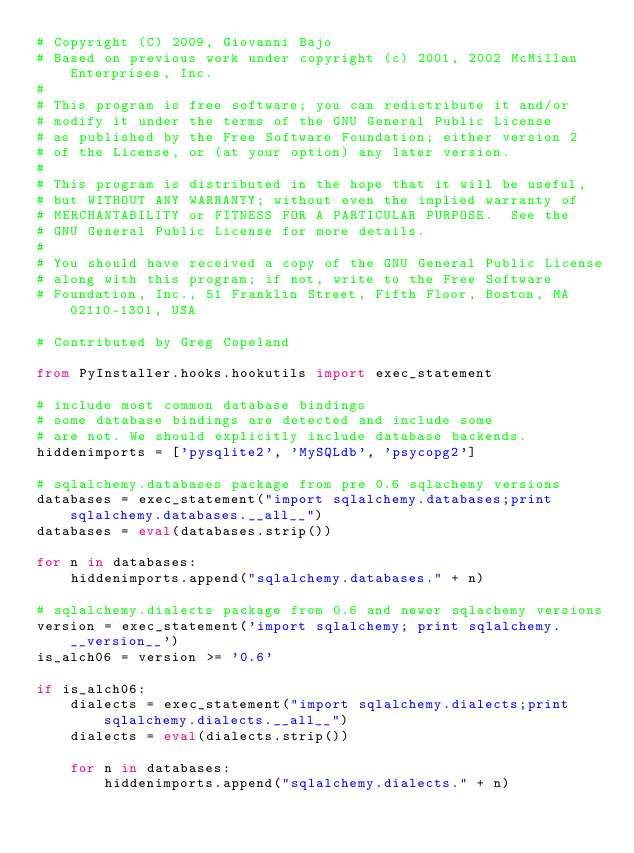Convert code to text. <code><loc_0><loc_0><loc_500><loc_500><_Python_># Copyright (C) 2009, Giovanni Bajo
# Based on previous work under copyright (c) 2001, 2002 McMillan Enterprises, Inc.
#
# This program is free software; you can redistribute it and/or
# modify it under the terms of the GNU General Public License
# as published by the Free Software Foundation; either version 2
# of the License, or (at your option) any later version.
#
# This program is distributed in the hope that it will be useful,
# but WITHOUT ANY WARRANTY; without even the implied warranty of
# MERCHANTABILITY or FITNESS FOR A PARTICULAR PURPOSE.  See the
# GNU General Public License for more details.
#
# You should have received a copy of the GNU General Public License
# along with this program; if not, write to the Free Software
# Foundation, Inc., 51 Franklin Street, Fifth Floor, Boston, MA  02110-1301, USA

# Contributed by Greg Copeland

from PyInstaller.hooks.hookutils import exec_statement

# include most common database bindings
# some database bindings are detected and include some
# are not. We should explicitly include database backends.
hiddenimports = ['pysqlite2', 'MySQLdb', 'psycopg2']

# sqlalchemy.databases package from pre 0.6 sqlachemy versions
databases = exec_statement("import sqlalchemy.databases;print sqlalchemy.databases.__all__")
databases = eval(databases.strip())

for n in databases:
    hiddenimports.append("sqlalchemy.databases." + n)

# sqlalchemy.dialects package from 0.6 and newer sqlachemy versions
version = exec_statement('import sqlalchemy; print sqlalchemy.__version__')
is_alch06 = version >= '0.6'

if is_alch06:
    dialects = exec_statement("import sqlalchemy.dialects;print sqlalchemy.dialects.__all__")
    dialects = eval(dialects.strip())

    for n in databases:
        hiddenimports.append("sqlalchemy.dialects." + n)
</code> 